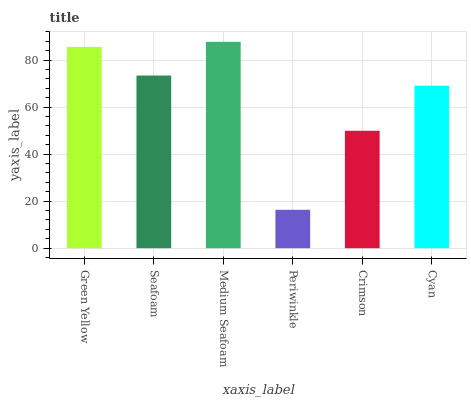Is Seafoam the minimum?
Answer yes or no. No. Is Seafoam the maximum?
Answer yes or no. No. Is Green Yellow greater than Seafoam?
Answer yes or no. Yes. Is Seafoam less than Green Yellow?
Answer yes or no. Yes. Is Seafoam greater than Green Yellow?
Answer yes or no. No. Is Green Yellow less than Seafoam?
Answer yes or no. No. Is Seafoam the high median?
Answer yes or no. Yes. Is Cyan the low median?
Answer yes or no. Yes. Is Periwinkle the high median?
Answer yes or no. No. Is Periwinkle the low median?
Answer yes or no. No. 